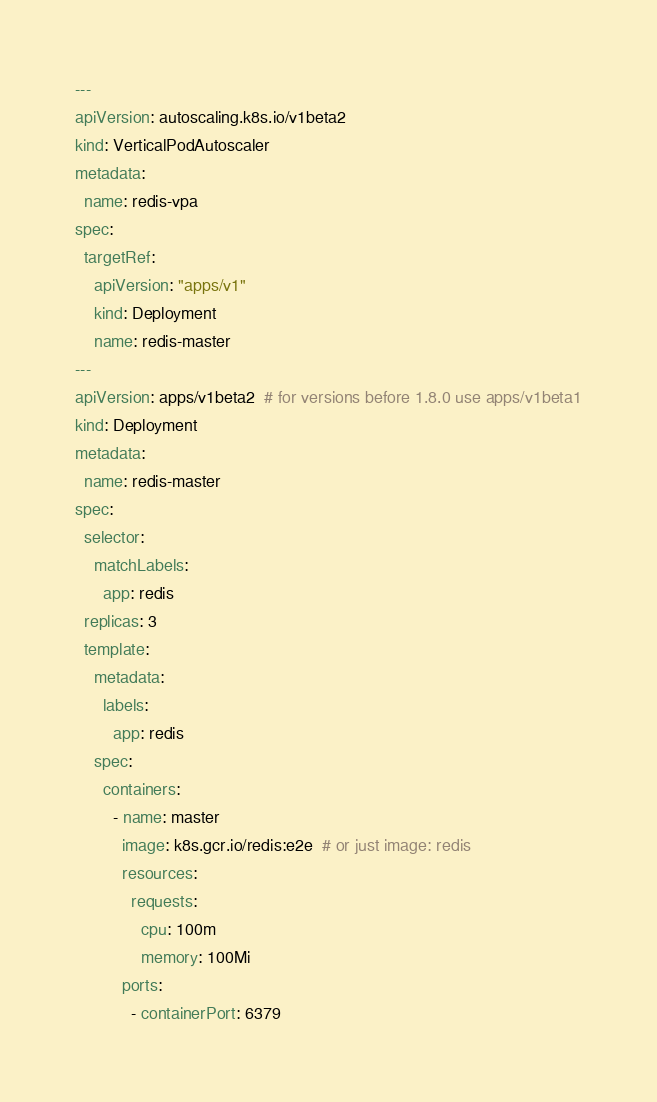<code> <loc_0><loc_0><loc_500><loc_500><_YAML_>---
apiVersion: autoscaling.k8s.io/v1beta2
kind: VerticalPodAutoscaler
metadata:
  name: redis-vpa
spec:
  targetRef:
    apiVersion: "apps/v1"
    kind: Deployment
    name: redis-master
---
apiVersion: apps/v1beta2  # for versions before 1.8.0 use apps/v1beta1
kind: Deployment
metadata:
  name: redis-master
spec:
  selector:
    matchLabels:
      app: redis
  replicas: 3
  template:
    metadata:
      labels:
        app: redis
    spec:
      containers:
        - name: master
          image: k8s.gcr.io/redis:e2e  # or just image: redis
          resources:
            requests:
              cpu: 100m
              memory: 100Mi
          ports:
            - containerPort: 6379
</code> 